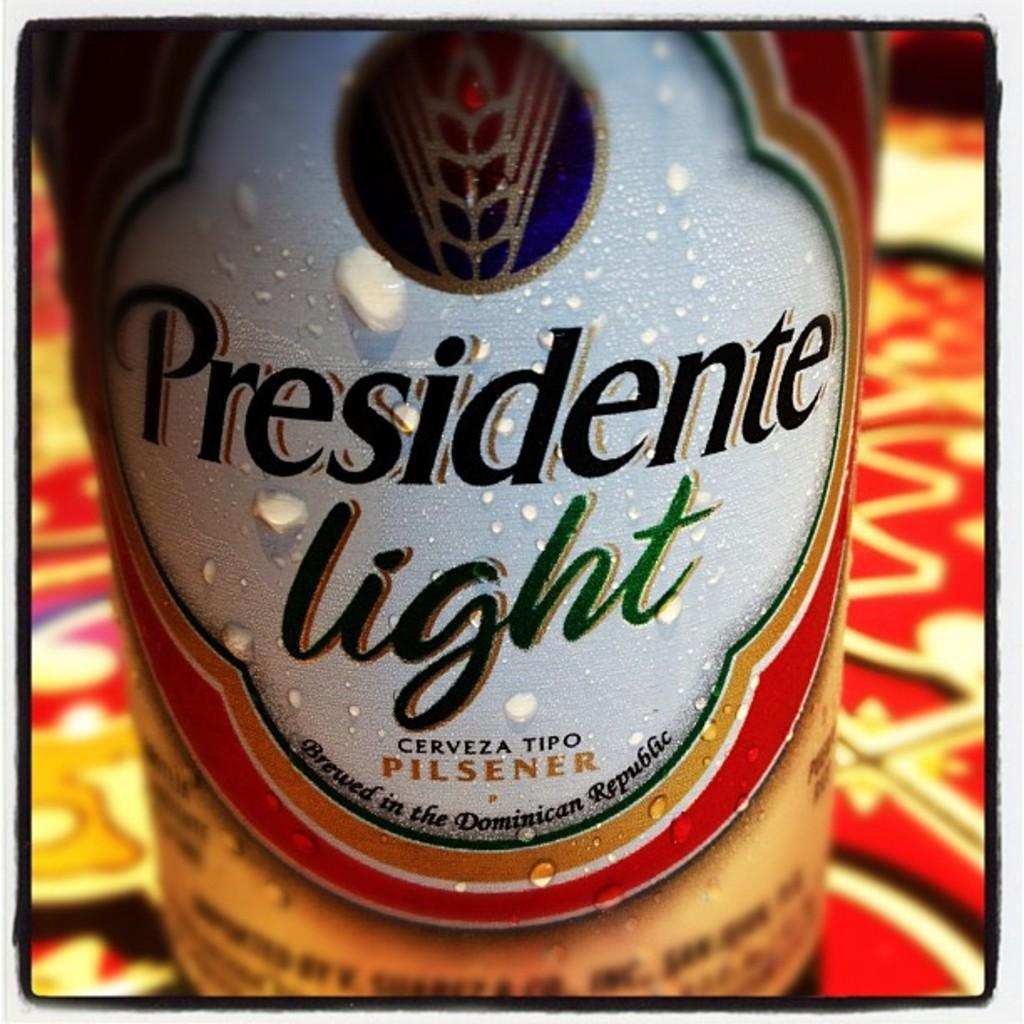<image>
Render a clear and concise summary of the photo. a bottled of beer called Presidente light pilsner 